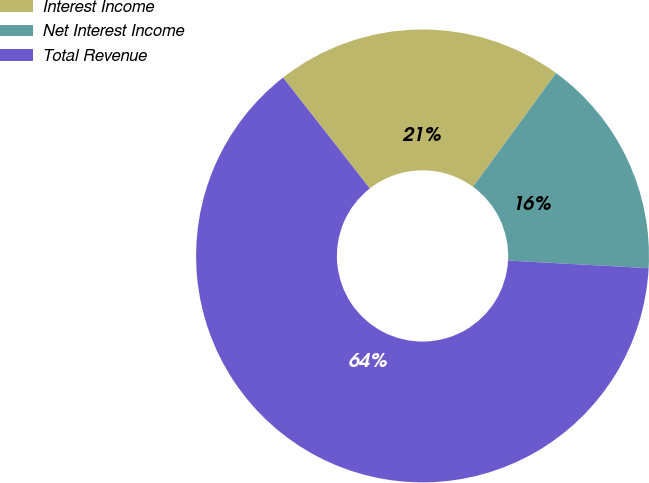Convert chart. <chart><loc_0><loc_0><loc_500><loc_500><pie_chart><fcel>Interest Income<fcel>Net Interest Income<fcel>Total Revenue<nl><fcel>20.6%<fcel>15.82%<fcel>63.58%<nl></chart> 